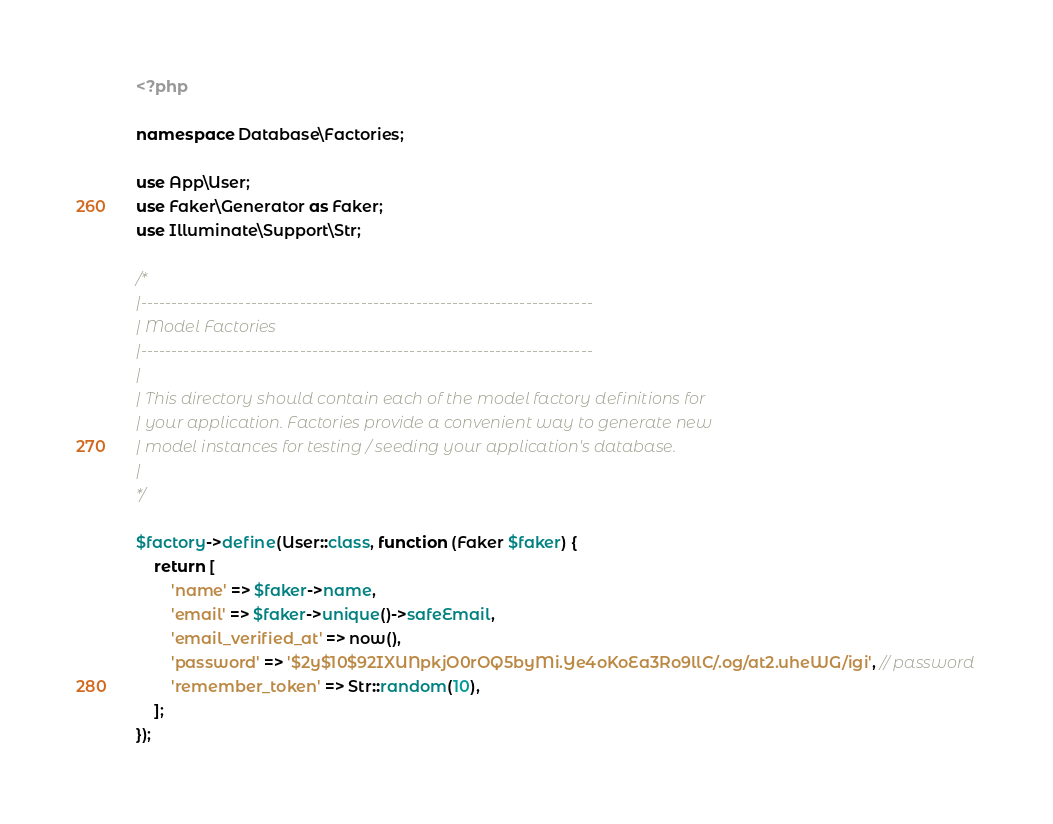Convert code to text. <code><loc_0><loc_0><loc_500><loc_500><_PHP_><?php

namespace Database\Factories;

use App\User;
use Faker\Generator as Faker;
use Illuminate\Support\Str;

/*
|--------------------------------------------------------------------------
| Model Factories
|--------------------------------------------------------------------------
|
| This directory should contain each of the model factory definitions for
| your application. Factories provide a convenient way to generate new
| model instances for testing / seeding your application's database.
|
*/

$factory->define(User::class, function (Faker $faker) {
    return [
        'name' => $faker->name,
        'email' => $faker->unique()->safeEmail,
        'email_verified_at' => now(),
        'password' => '$2y$10$92IXUNpkjO0rOQ5byMi.Ye4oKoEa3Ro9llC/.og/at2.uheWG/igi', // password
        'remember_token' => Str::random(10),
    ];
});
</code> 